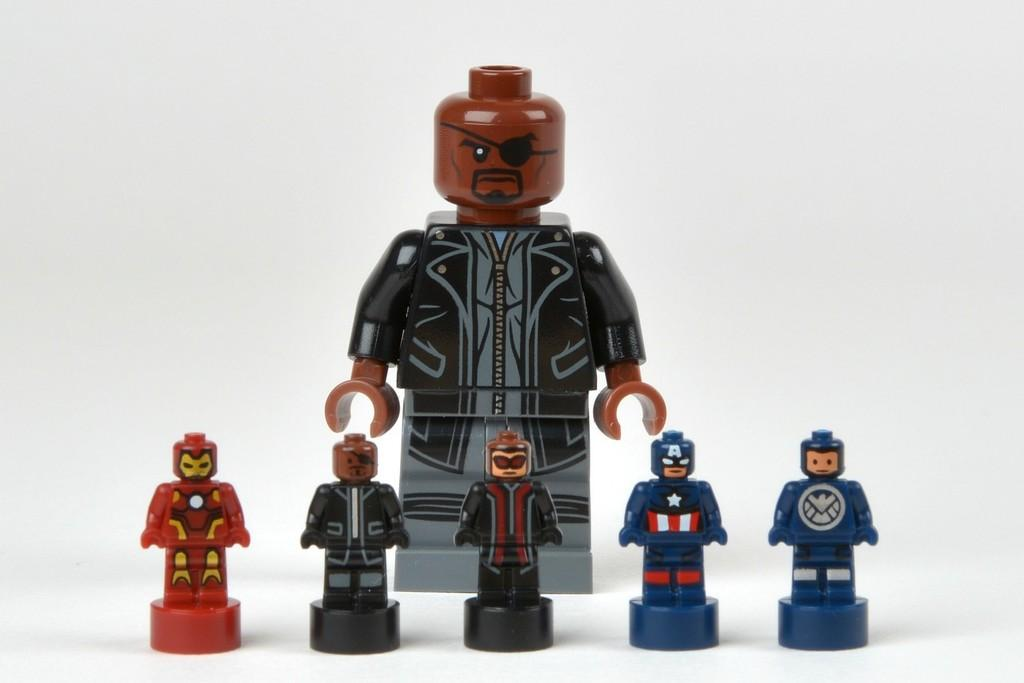How many toys are visible on the platform in the image? There are six toys on a platform in the image. What can be seen in the background of the image? The background of the image is white. What type of pet is visible in the image? There is no pet present in the image. Can you see a zipper on any of the toys in the image? The toys in the image do not have any visible zippers. 